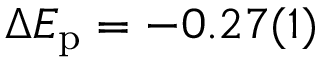Convert formula to latex. <formula><loc_0><loc_0><loc_500><loc_500>\Delta E _ { p } = - 0 . 2 7 ( 1 )</formula> 